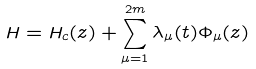<formula> <loc_0><loc_0><loc_500><loc_500>H = H _ { c } ( z ) + \sum _ { \mu = 1 } ^ { 2 m } \lambda _ { \mu } ( t ) \Phi _ { \mu } ( z )</formula> 